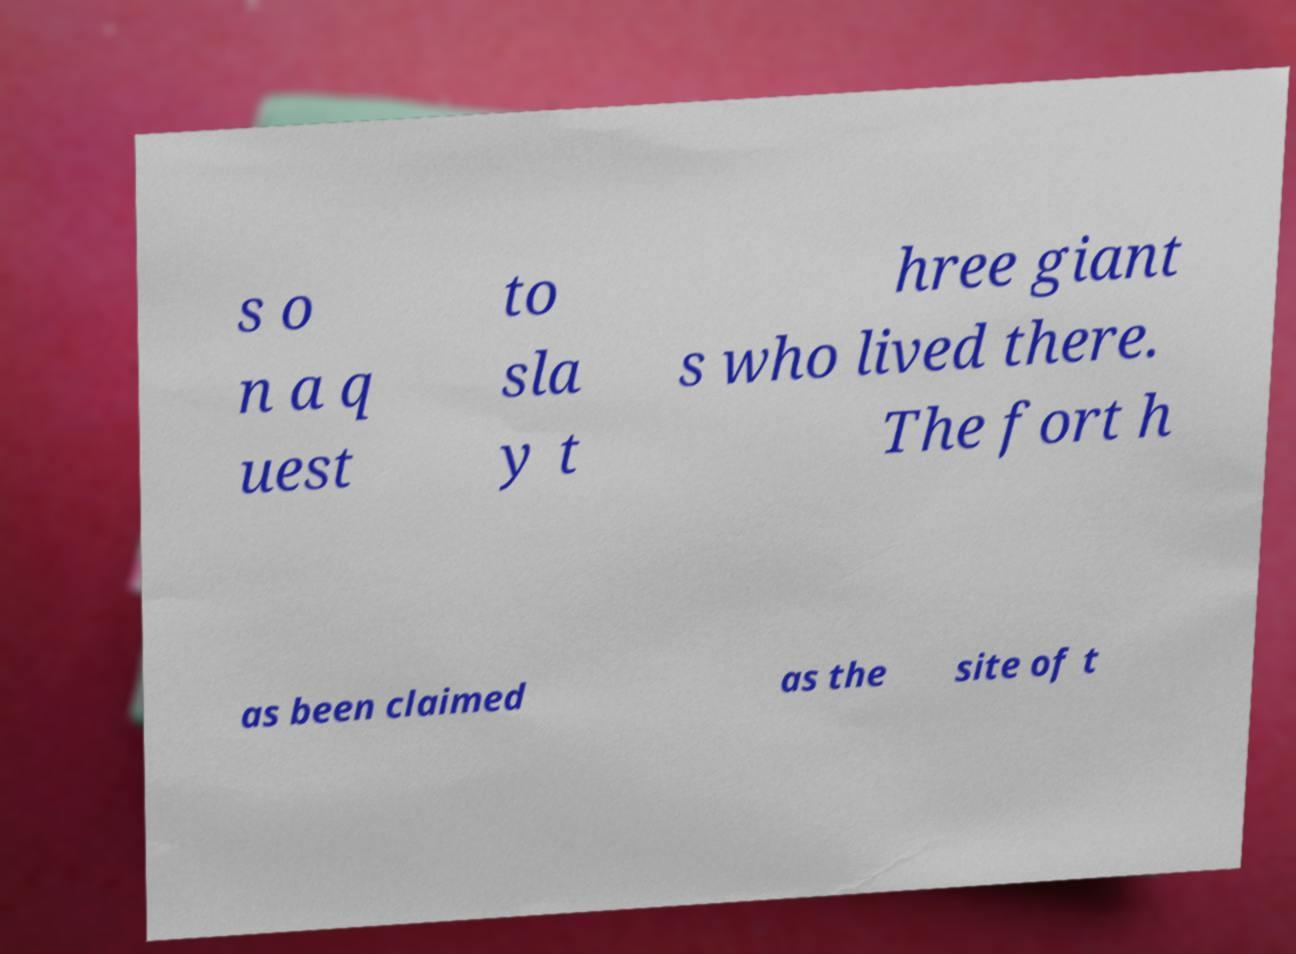I need the written content from this picture converted into text. Can you do that? s o n a q uest to sla y t hree giant s who lived there. The fort h as been claimed as the site of t 